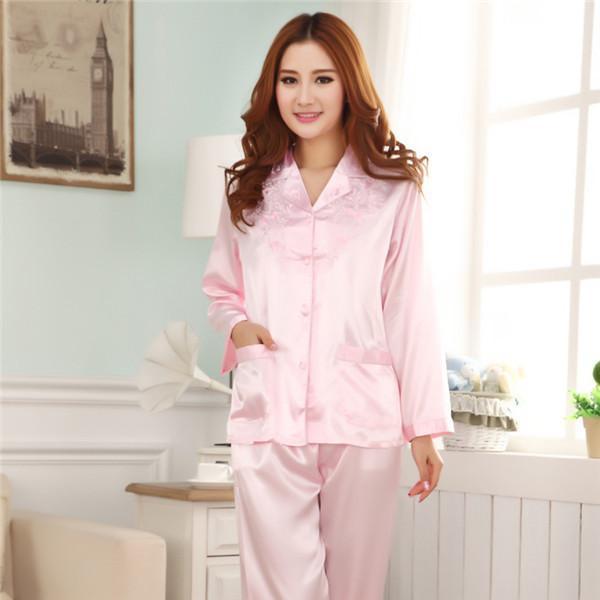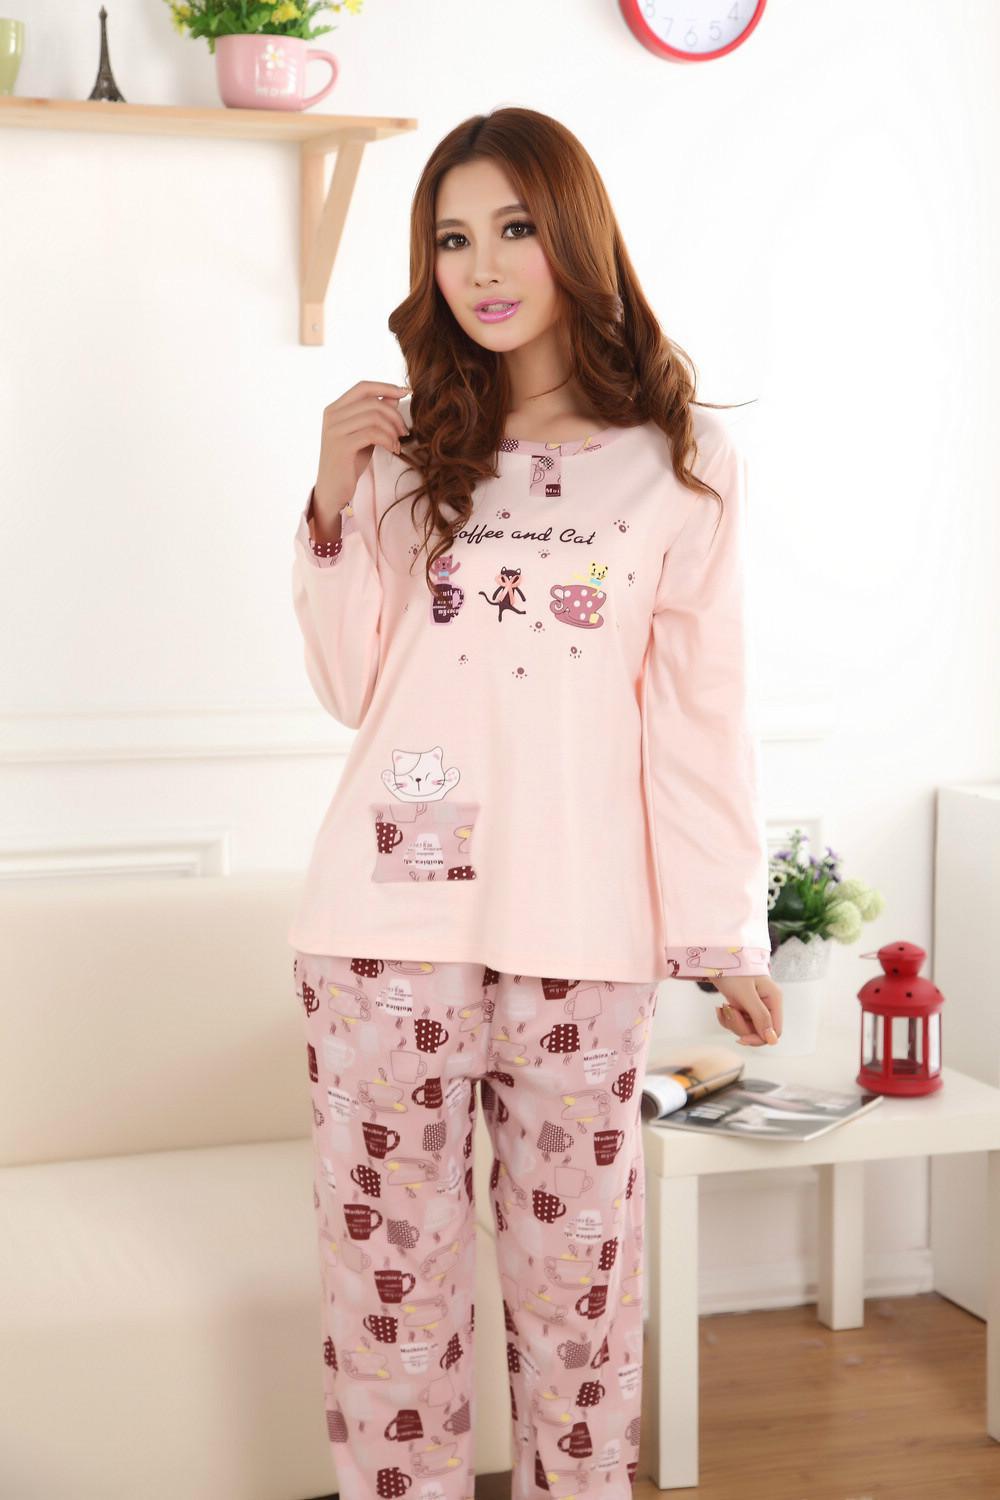The first image is the image on the left, the second image is the image on the right. Assess this claim about the two images: "There is a woman facing right in the left image.". Correct or not? Answer yes or no. No. 